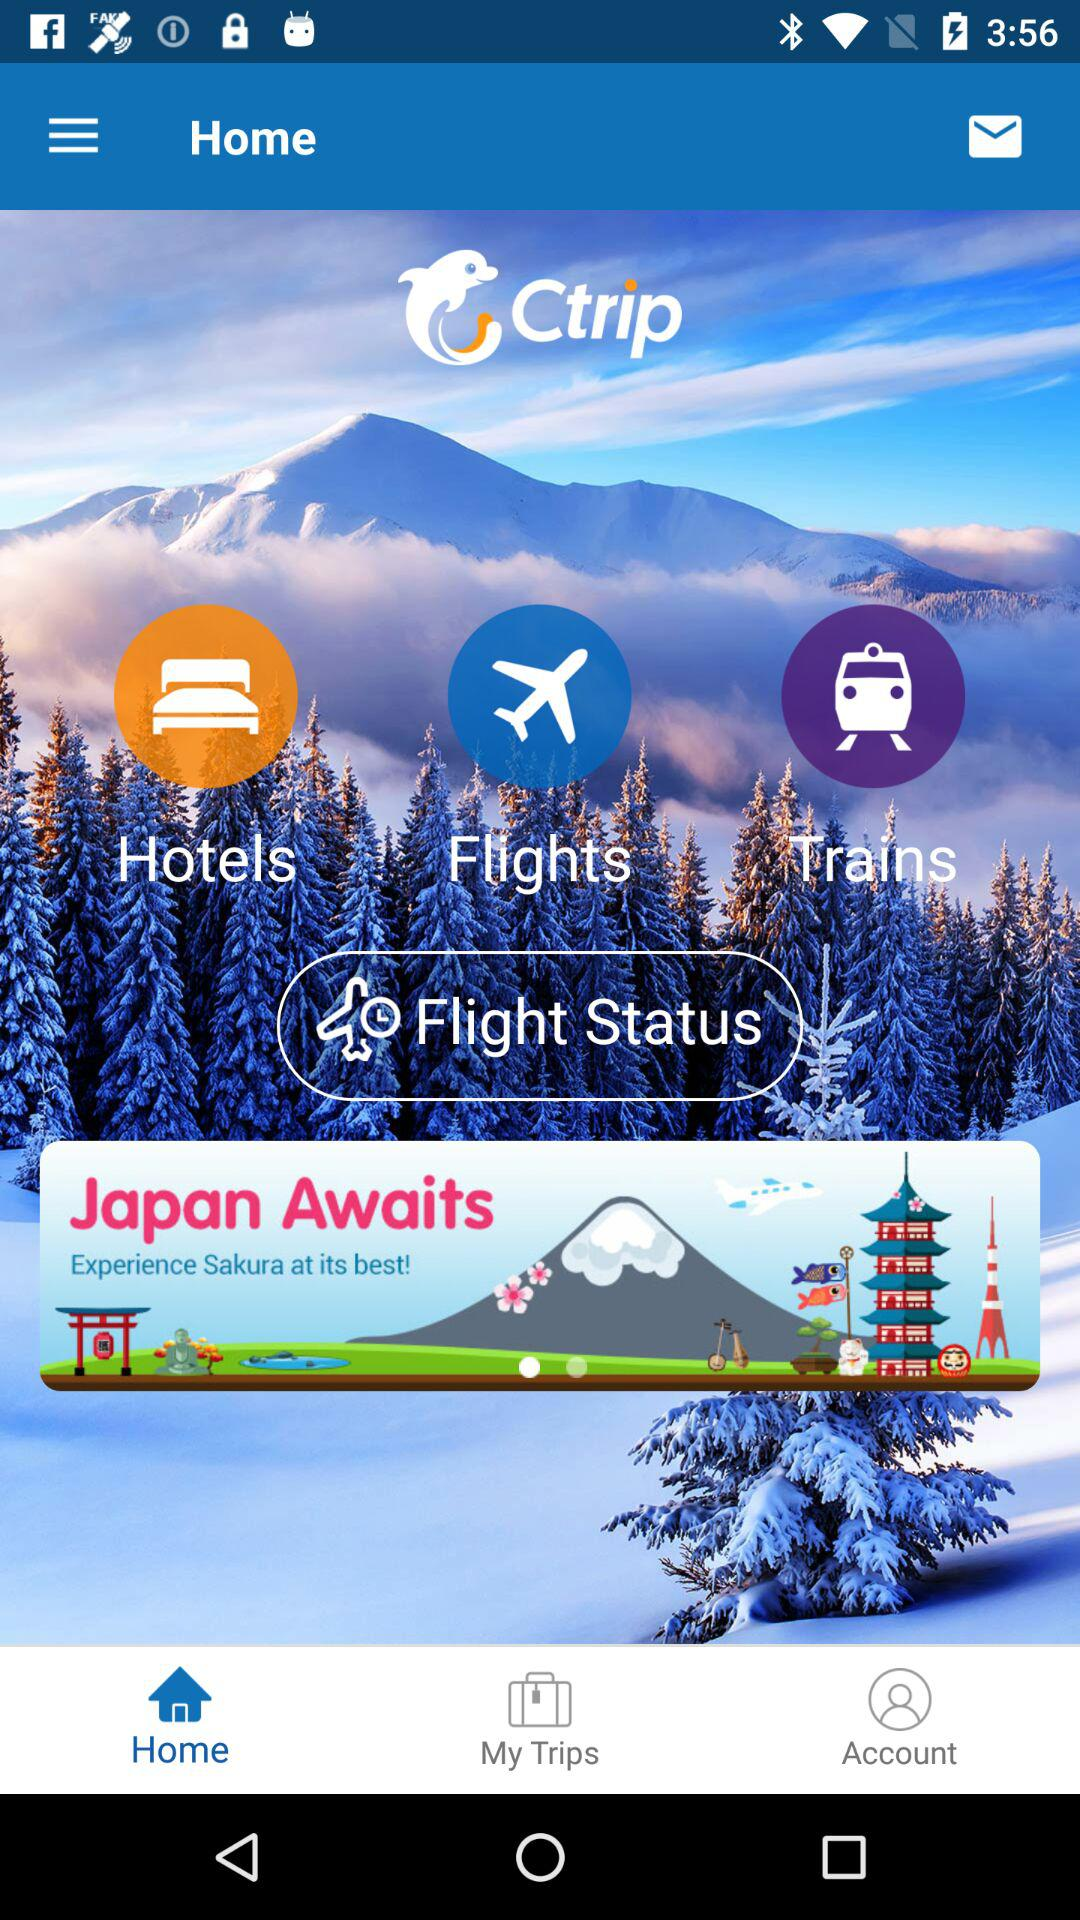Which tab is selected? The selected tab is "Home". 